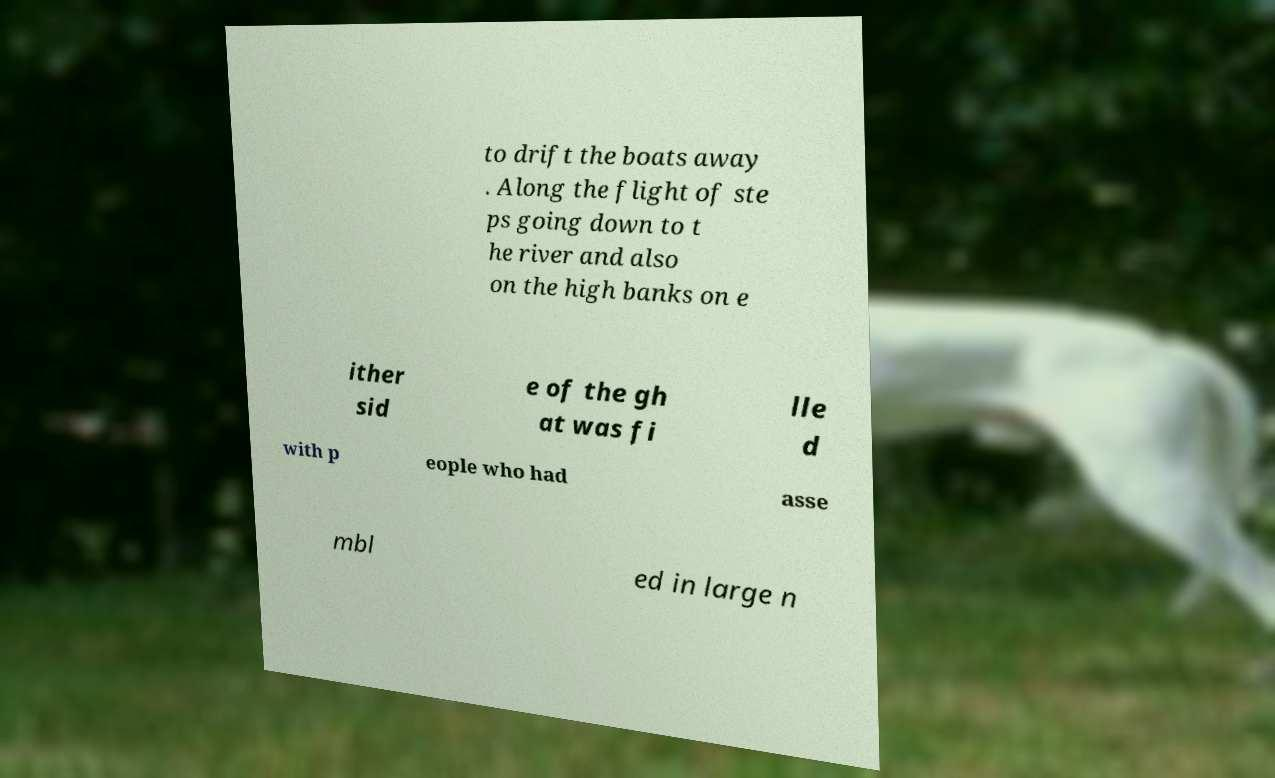There's text embedded in this image that I need extracted. Can you transcribe it verbatim? to drift the boats away . Along the flight of ste ps going down to t he river and also on the high banks on e ither sid e of the gh at was fi lle d with p eople who had asse mbl ed in large n 